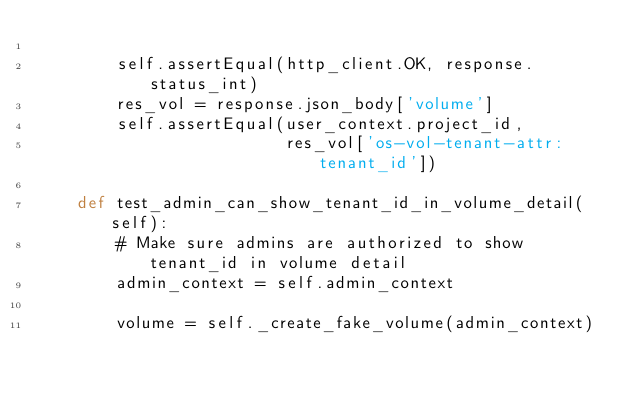Convert code to text. <code><loc_0><loc_0><loc_500><loc_500><_Python_>
        self.assertEqual(http_client.OK, response.status_int)
        res_vol = response.json_body['volume']
        self.assertEqual(user_context.project_id,
                         res_vol['os-vol-tenant-attr:tenant_id'])

    def test_admin_can_show_tenant_id_in_volume_detail(self):
        # Make sure admins are authorized to show tenant_id in volume detail
        admin_context = self.admin_context

        volume = self._create_fake_volume(admin_context)</code> 